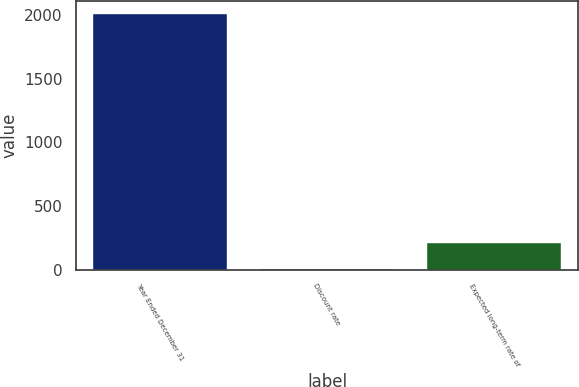Convert chart to OTSL. <chart><loc_0><loc_0><loc_500><loc_500><bar_chart><fcel>Year Ended December 31<fcel>Discount rate<fcel>Expected long-term rate of<nl><fcel>2013<fcel>4<fcel>204.9<nl></chart> 